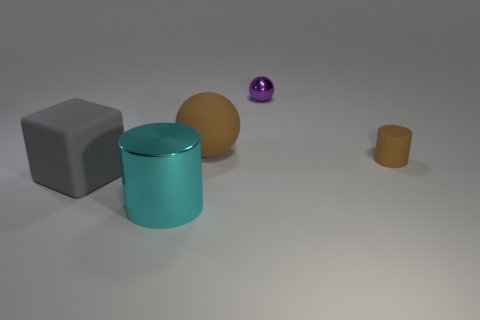What number of rubber objects are tiny cylinders or large purple cylinders?
Provide a succinct answer. 1. What shape is the tiny brown thing that is the same material as the big gray thing?
Keep it short and to the point. Cylinder. How many matte things are on the right side of the block and left of the brown cylinder?
Offer a very short reply. 1. Is there any other thing that is the same shape as the big cyan shiny object?
Make the answer very short. Yes. There is a matte thing behind the tiny rubber object; what is its size?
Make the answer very short. Large. How many other objects are the same color as the big ball?
Offer a terse response. 1. What is the material of the cylinder on the right side of the brown object left of the small rubber object?
Your answer should be very brief. Rubber. Does the matte object behind the tiny brown thing have the same color as the tiny matte object?
Offer a very short reply. Yes. How many other big cyan objects have the same shape as the cyan shiny thing?
Your answer should be compact. 0. What size is the cylinder that is made of the same material as the large gray block?
Offer a very short reply. Small. 